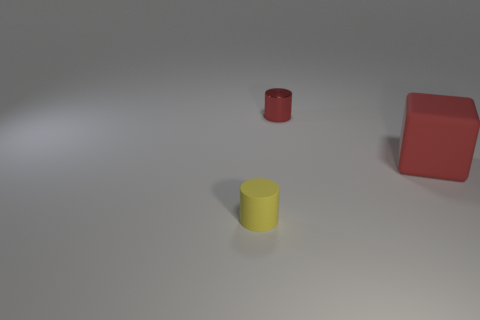There is a tiny red metallic object that is to the right of the cylinder that is in front of the metal object; what is its shape?
Your response must be concise. Cylinder. How many cubes are in front of the tiny red metal object?
Your answer should be very brief. 1. There is a large object that is the same material as the yellow cylinder; what is its color?
Provide a succinct answer. Red. There is a red metal thing; is its size the same as the rubber thing that is left of the large thing?
Give a very brief answer. Yes. What is the size of the matte thing right of the thing that is on the left side of the cylinder that is behind the yellow cylinder?
Offer a terse response. Large. What number of rubber objects are large red things or tiny cylinders?
Your answer should be very brief. 2. The cylinder left of the red metal object is what color?
Offer a terse response. Yellow. There is a tiny metal cylinder; is it the same color as the matte object to the right of the red shiny cylinder?
Ensure brevity in your answer.  Yes. How many objects are tiny cylinders to the right of the tiny yellow matte cylinder or objects that are in front of the tiny red metal thing?
Your answer should be very brief. 3. There is another cylinder that is the same size as the yellow cylinder; what material is it?
Keep it short and to the point. Metal. 